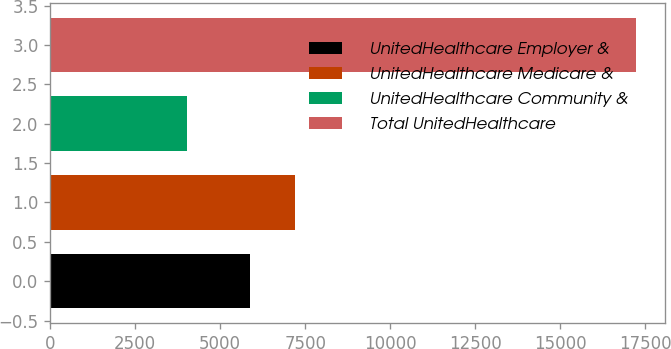Convert chart to OTSL. <chart><loc_0><loc_0><loc_500><loc_500><bar_chart><fcel>UnitedHealthcare Employer &<fcel>UnitedHealthcare Medicare &<fcel>UnitedHealthcare Community &<fcel>Total UnitedHealthcare<nl><fcel>5890<fcel>7210.4<fcel>4034<fcel>17238<nl></chart> 